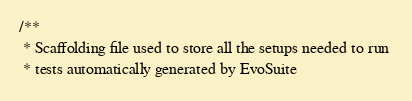Convert code to text. <code><loc_0><loc_0><loc_500><loc_500><_Java_>/**
 * Scaffolding file used to store all the setups needed to run 
 * tests automatically generated by EvoSuite</code> 